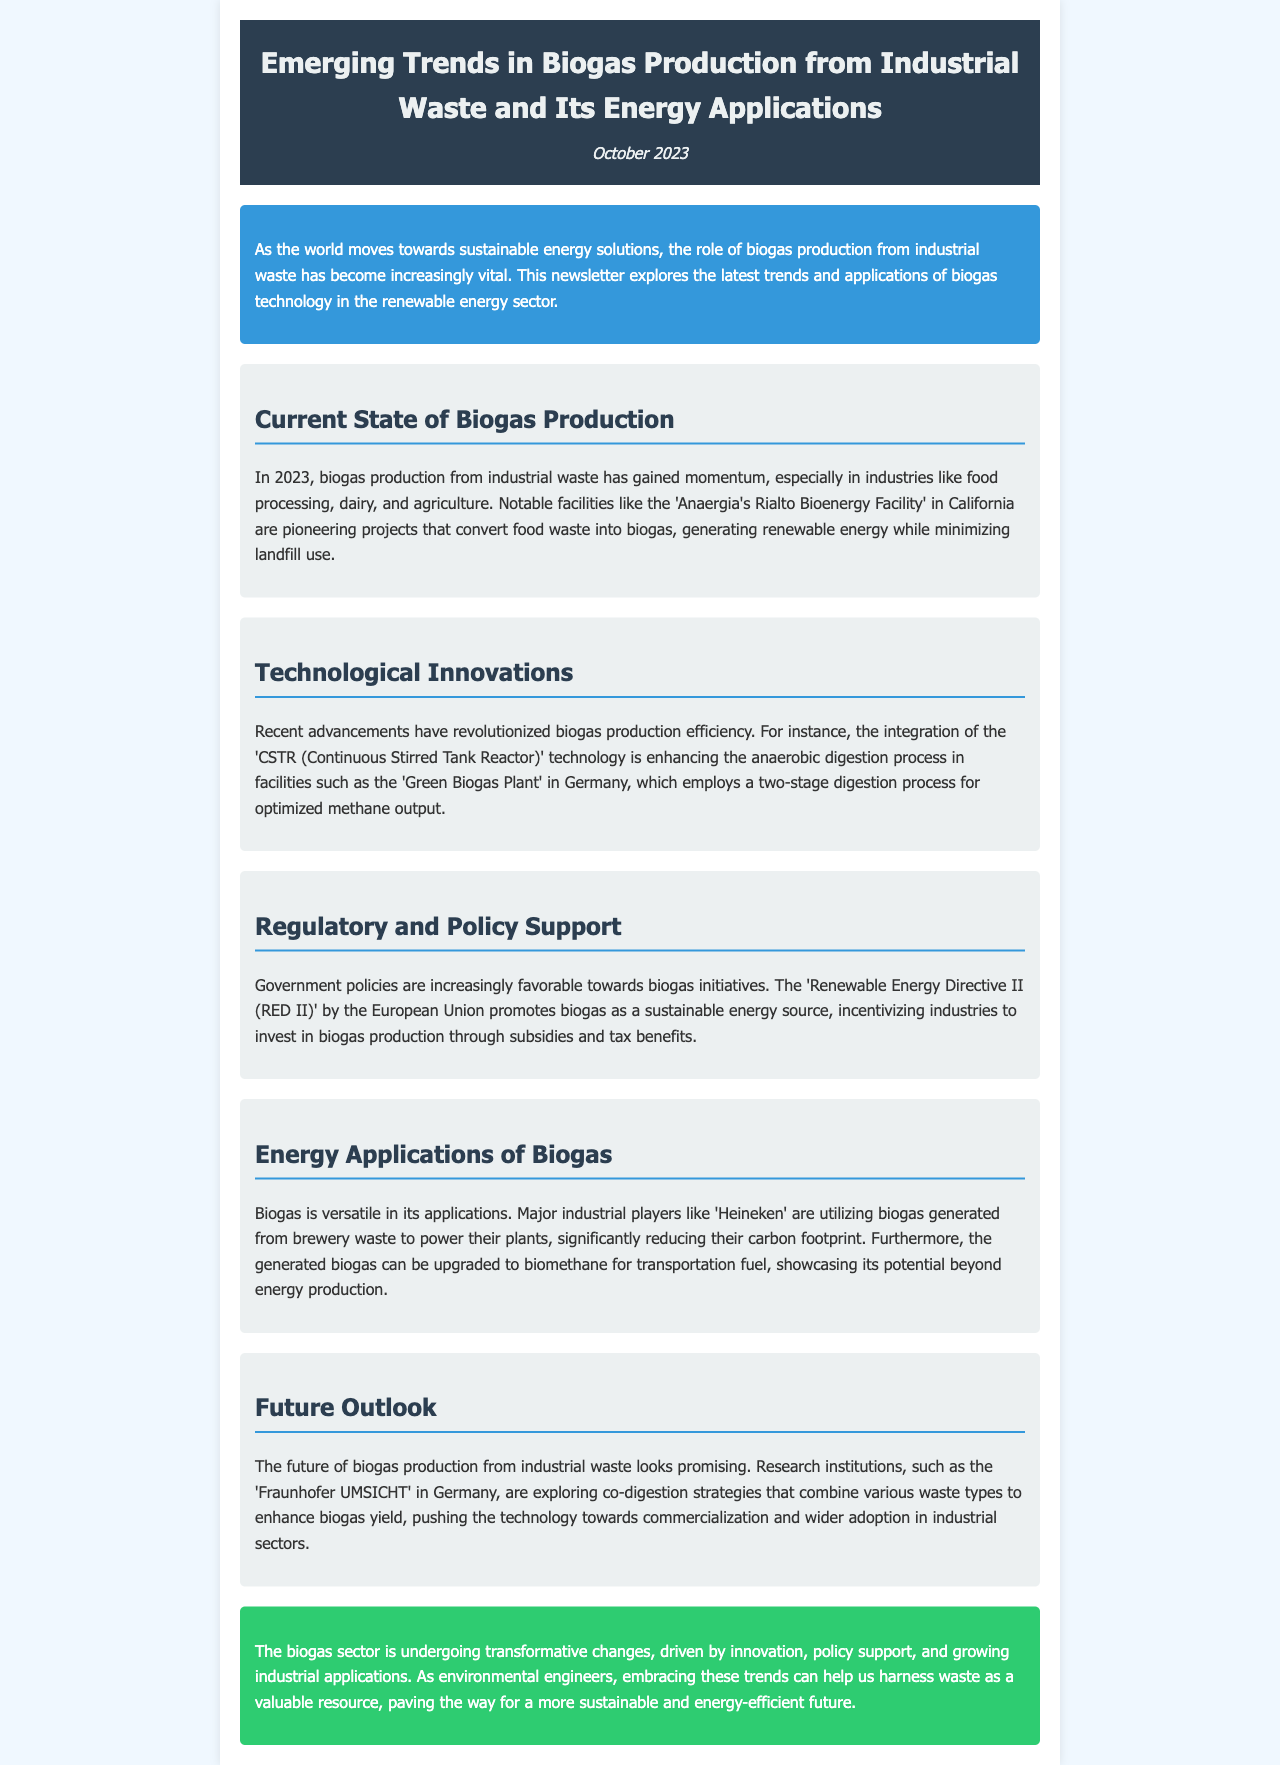What industry is mentioned as gaining momentum in biogas production? The document states that biogas production has gained momentum in industries like food processing, dairy, and agriculture.
Answer: food processing, dairy, agriculture What facility is highlighted for converting food waste into biogas? The newsletter mentions 'Anaergia's Rialto Bioenergy Facility' in California as a notable facility for converting food waste into biogas.
Answer: Anaergia's Rialto Bioenergy Facility Which technology is enhancing anaerobic digestion efficiency? The document describes the integration of the 'CSTR (Continuous Stirred Tank Reactor)' technology as enhancing anaerobic digestion efficiency.
Answer: CSTR What directive promotes biogas as a sustainable energy source in the EU? The 'Renewable Energy Directive II (RED II)' by the European Union is mentioned as promoting biogas as a sustainable energy source.
Answer: Renewable Energy Directive II (RED II) Which company uses biogas from brewery waste to power its plants? The newsletter states that 'Heineken' utilizes biogas generated from brewery waste to power their plants.
Answer: Heineken What future strategy is being explored to enhance biogas yield? The document notes that research institutions are exploring co-digestion strategies to enhance biogas yield.
Answer: co-digestion strategies What is the overall sentiment towards the future of biogas production? The text conveys a promising outlook for biogas production from industrial waste.
Answer: promising When was the newsletter published? The publication date mentioned in the header is October 2023.
Answer: October 2023 